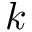<formula> <loc_0><loc_0><loc_500><loc_500>k</formula> 